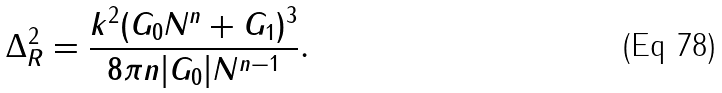<formula> <loc_0><loc_0><loc_500><loc_500>\Delta _ { R } ^ { 2 } = \frac { k ^ { 2 } ( G _ { 0 } N ^ { n } + G _ { 1 } ) ^ { 3 } } { 8 \pi n | G _ { 0 } | N ^ { n - 1 } } .</formula> 